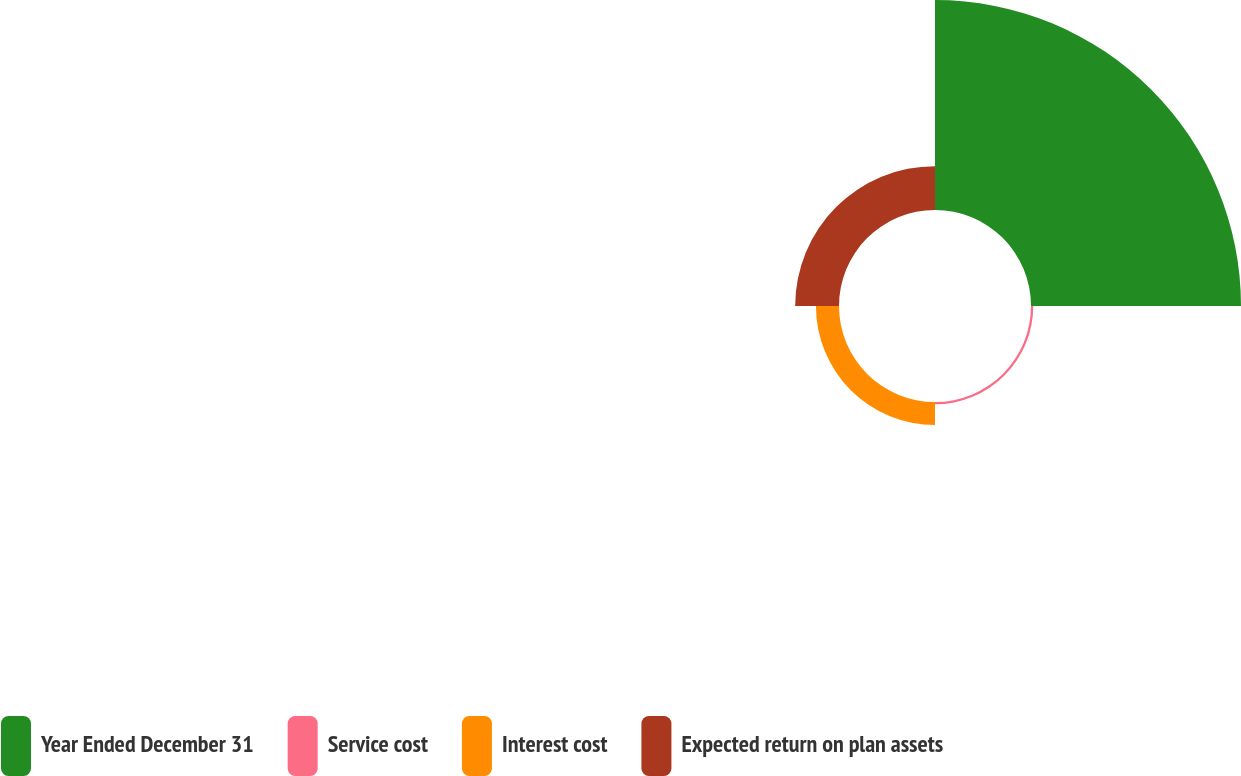Convert chart. <chart><loc_0><loc_0><loc_500><loc_500><pie_chart><fcel>Year Ended December 31<fcel>Service cost<fcel>Interest cost<fcel>Expected return on plan assets<nl><fcel>75.22%<fcel>0.82%<fcel>8.26%<fcel>15.7%<nl></chart> 